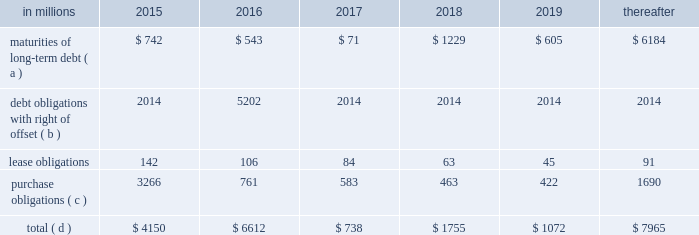On the credit rating of the company and a $ 200 million term loan with an interest rate of libor plus a margin of 175 basis points , both with maturity dates in 2017 .
The proceeds from these borrowings were used , along with available cash , to fund the acquisition of temple- inland .
During 2012 , international paper fully repaid the $ 1.2 billion term loan .
International paper utilizes interest rate swaps to change the mix of fixed and variable rate debt and manage interest expense .
At december 31 , 2012 , international paper had interest rate swaps with a total notional amount of $ 150 million and maturities in 2013 ( see note 14 derivatives and hedging activities on pages 70 through 74 of item 8 .
Financial statements and supplementary data ) .
During 2012 , existing swaps and the amortization of deferred gains on previously terminated swaps decreased the weighted average cost of debt from 6.8% ( 6.8 % ) to an effective rate of 6.6% ( 6.6 % ) .
The inclusion of the offsetting interest income from short- term investments reduced this effective rate to 6.2% ( 6.2 % ) .
Other financing activities during 2012 included the issuance of approximately 1.9 million shares of treasury stock , net of restricted stock withholding , and 1.0 million shares of common stock for various incentive plans , including stock options exercises that generated approximately $ 108 million of cash .
Payment of restricted stock withholding taxes totaled $ 35 million .
Off-balance sheet variable interest entities information concerning off-balance sheet variable interest entities is set forth in note 12 variable interest entities and preferred securities of subsidiaries on pages 67 through 69 of item 8 .
Financial statements and supplementary data for discussion .
Liquidity and capital resources outlook for 2015 capital expenditures and long-term debt international paper expects to be able to meet projected capital expenditures , service existing debt and meet working capital and dividend requirements during 2015 through current cash balances and cash from operations .
Additionally , the company has existing credit facilities totaling $ 2.0 billion of which nothing has been used .
The company was in compliance with all its debt covenants at december 31 , 2014 .
The company 2019s financial covenants require the maintenance of a minimum net worth of $ 9 billion and a total debt-to- capital ratio of less than 60% ( 60 % ) .
Net worth is defined as the sum of common stock , paid-in capital and retained earnings , less treasury stock plus any cumulative goodwill impairment charges .
The calculation also excludes accumulated other comprehensive income/ loss and nonrecourse financial liabilities of special purpose entities .
The total debt-to-capital ratio is defined as total debt divided by the sum of total debt plus net worth .
At december 31 , 2014 , international paper 2019s net worth was $ 14.0 billion , and the total-debt- to-capital ratio was 40% ( 40 % ) .
The company will continue to rely upon debt and capital markets for the majority of any necessary long-term funding not provided by operating cash flows .
Funding decisions will be guided by our capital structure planning objectives .
The primary goals of the company 2019s capital structure planning are to maximize financial flexibility and preserve liquidity while reducing interest expense .
The majority of international paper 2019s debt is accessed through global public capital markets where we have a wide base of investors .
Maintaining an investment grade credit rating is an important element of international paper 2019s financing strategy .
At december 31 , 2014 , the company held long-term credit ratings of bbb ( stable outlook ) and baa2 ( stable outlook ) by s&p and moody 2019s , respectively .
Contractual obligations for future payments under existing debt and lease commitments and purchase obligations at december 31 , 2014 , were as follows: .
( a ) total debt includes scheduled principal payments only .
( b ) represents debt obligations borrowed from non-consolidated variable interest entities for which international paper has , and intends to effect , a legal right to offset these obligations with investments held in the entities .
Accordingly , in its consolidated balance sheet at december 31 , 2014 , international paper has offset approximately $ 5.2 billion of interests in the entities against this $ 5.3 billion of debt obligations held by the entities ( see note 12 variable interest entities and preferred securities of subsidiaries on pages 67 through 69 in item 8 .
Financial statements and supplementary data ) .
( c ) includes $ 2.3 billion relating to fiber supply agreements entered into at the time of the 2006 transformation plan forestland sales and in conjunction with the 2008 acquisition of weyerhaeuser company 2019s containerboard , packaging and recycling business .
( d ) not included in the above table due to the uncertainty as to the amount and timing of the payment are unrecognized tax benefits of approximately $ 119 million .
As discussed in note 12 variable interest entities and preferred securities of subsidiaries on pages 67 through 69 in item 8 .
Financial statements and supplementary data , in connection with the 2006 international paper installment sale of forestlands , we received $ 4.8 billion of installment notes ( or timber notes ) , which we contributed to certain non- consolidated borrower entities .
The installment notes mature in august 2016 ( unless extended ) .
The deferred .
What percentage of contractual obligations for future payments under existing debt and lease commitments and purchase obligations at december 31 , 2014 due in 2015 are purchase obligations? 
Computations: (3266 / 4150)
Answer: 0.78699. 